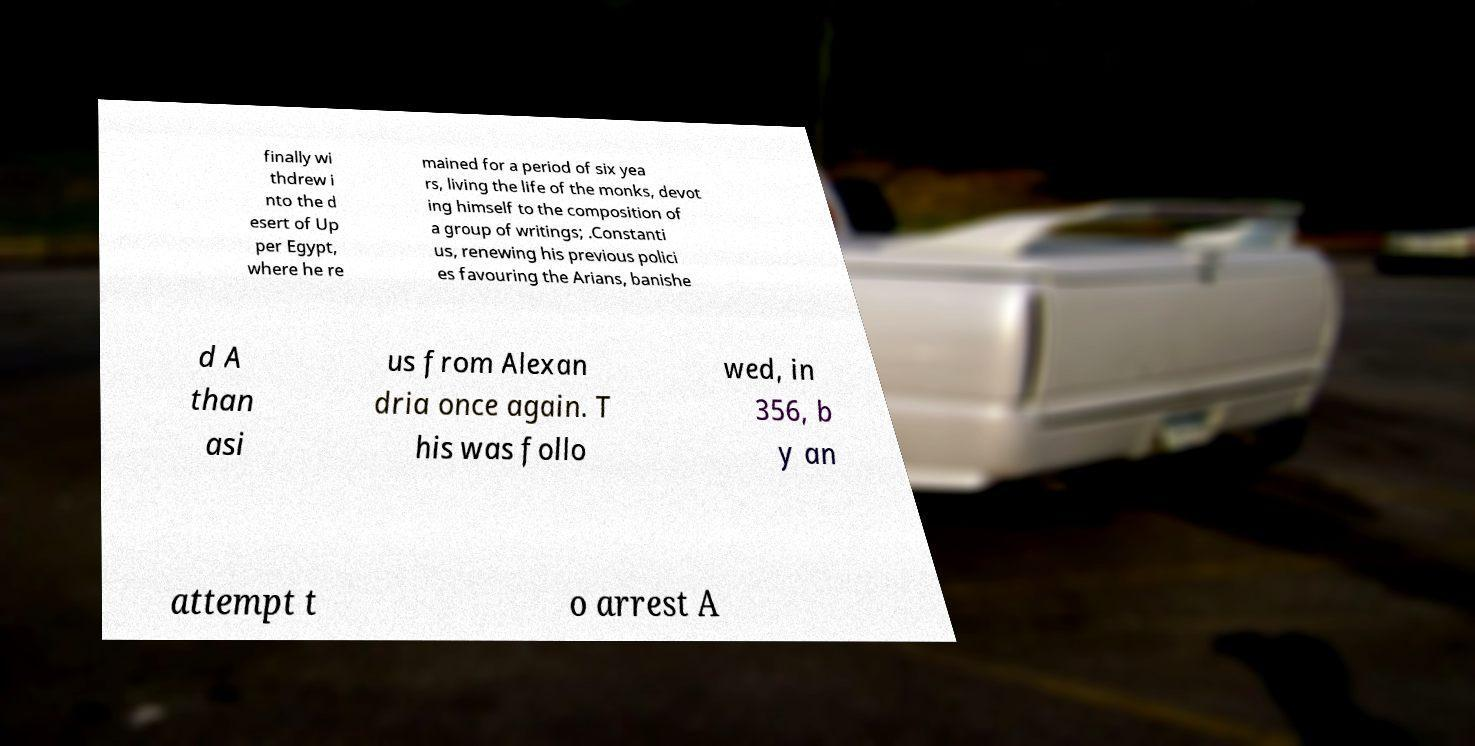Could you extract and type out the text from this image? finally wi thdrew i nto the d esert of Up per Egypt, where he re mained for a period of six yea rs, living the life of the monks, devot ing himself to the composition of a group of writings; .Constanti us, renewing his previous polici es favouring the Arians, banishe d A than asi us from Alexan dria once again. T his was follo wed, in 356, b y an attempt t o arrest A 